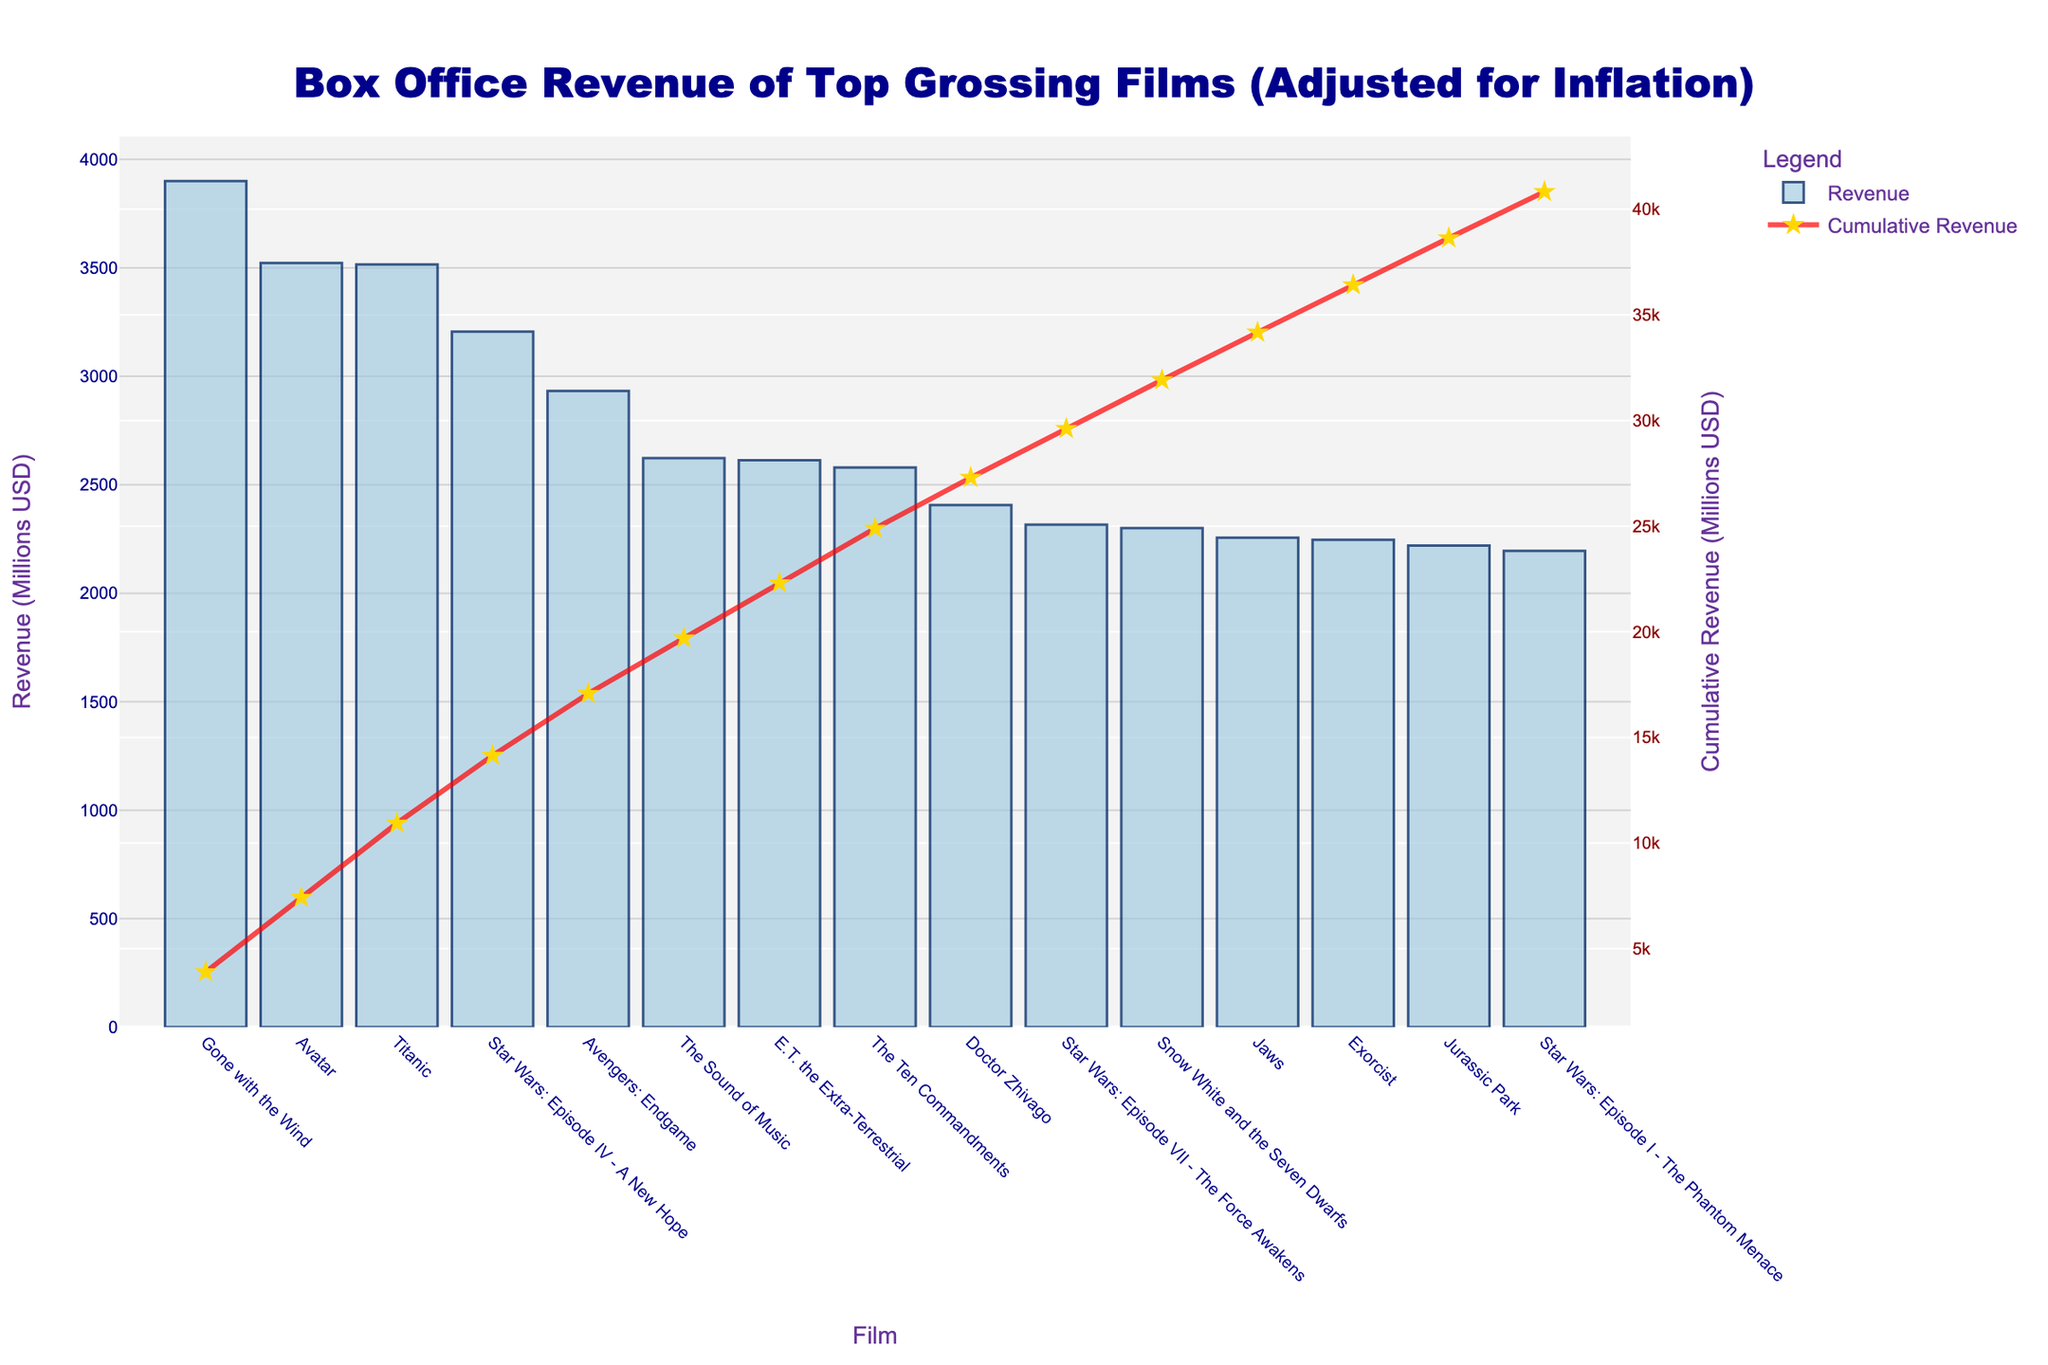What's the film with the highest box office revenue? The highest bar in the chart represents the film with the greatest box office revenue. By looking at the chart, "Gone with the Wind" has the highest bar.
Answer: Gone with the Wind Which film earned more at the box office, "Avatar" or "Titanic"? To determine which film earned more, compare the heights of the bars corresponding to "Avatar" and "Titanic". "Avatar" has a taller bar than "Titanic".
Answer: Avatar By how much does the revenue of "Gone with the Wind" exceed "Avatar"? First, find the revenues of both films: "Gone with the Wind" earned 3900 million USD and "Avatar" earned 3522 million USD. Subtracting these values: 3900 - 3522 = 378.
Answer: 378 million USD What's the cumulative revenue of the top 3 highest-grossing films? Sum the revenues of the top 3 films: "Gone with the Wind" (3900 million USD), "Avatar" (3522 million USD), and "Titanic" (3515 million USD). The cumulative revenue is 3900 + 3522 + 3515 = 10937.
Answer: 10937 million USD Compare the revenue span between "E.T. the Extra-Terrestrial" and "Star Wars: Episode VII - The Force Awakens". Which one earned more? Compare the bars of "E.T. the Extra-Terrestrial" and "Star Wars: Episode VII - The Force Awakens". "E.T. the Extra-Terrestrial" has a taller bar indicating higher revenue.
Answer: E.T. the Extra-Terrestrial What is the revenue difference between "Star Wars: Episode IV - A New Hope" and "Star Wars: Episode VII - The Force Awakens"? Refer to their respective revenues: "Star Wars: Episode IV - A New Hope" earned 3206 million USD and "Star Wars: Episode VII - The Force Awakens" earned 2316 million USD. Subtracting these values: 3206 - 2316 = 890.
Answer: 890 million USD What percentage of the total revenue is contributed by "Avatar"? Total revenue from all films is the sum of individual revenues. First, sum the given revenues: 3900 + 3522 + 3515 + 3206 + 2932 + 2623 + 2613 + 2580 + 2407 + 2316 + 2300 + 2256 + 2246 + 2220 + 2195 = 42031 million USD. Now, calculate the percentage contribution of "Avatar": (3522 / 42031) * 100 ≈ 8.38%.
Answer: 8.38% How many films have a box office revenue greater than 3000 million USD? By inspecting the bars, observe that "Gone with the Wind", "Avatar", "Titanic", and "Star Wars: Episode IV - A New Hope" each have revenues greater than 3000 million USD.
Answer: 4 films Which film marks the cumulative revenue exceeding 10000 million USD for the first time? The cumulative revenue line helps us determine the point where it first exceeds 10000 million USD. The cumulative revenue just after "Titanic" (including its revenue) exceeds 10000 million USD: 3900 + 3522 + 3515 = 10937.
Answer: Titanic How much more revenue did "The Sound of Music" generate compared to "Jaws"? "The Sound of Music" and "Jaws" have revenues of 2623 million USD and 2256 million USD respectively. The difference is 2623 - 2256 = 367.
Answer: 367 million USD 